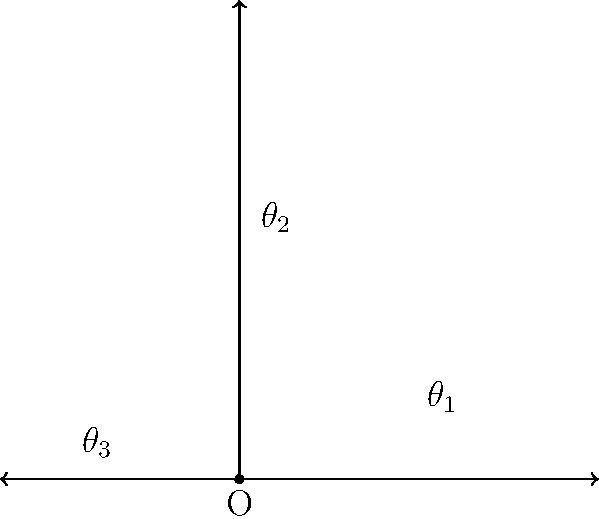In the Delos labs, a multi-armed robot similar to those used for host creation is being calibrated. The robot has three arms that can rotate independently around a central point O. If the first arm (OA) is at 0°, the second arm (OB) is at 90°, and the third arm (OC) is at 210°, what is the smallest positive angle between the first and third arms? Let's approach this step-by-step:

1) First, we need to understand the given information:
   - Arm OA is at 0°
   - Arm OB is at 90°
   - Arm OC is at 210°

2) We're asked to find the smallest positive angle between OA and OC.

3) The angle between OA and OC can be calculated by subtracting their angles:
   $210° - 0° = 210°$

4) However, in a circle, there are two ways to measure the angle between two points: clockwise and counterclockwise. We need to find the smaller of these two angles.

5) The other angle would be:
   $360° - 210° = 150°$

6) Comparing 210° and 150°, we see that 150° is the smaller angle.

Therefore, the smallest positive angle between the first and third arms is 150°.
Answer: 150° 